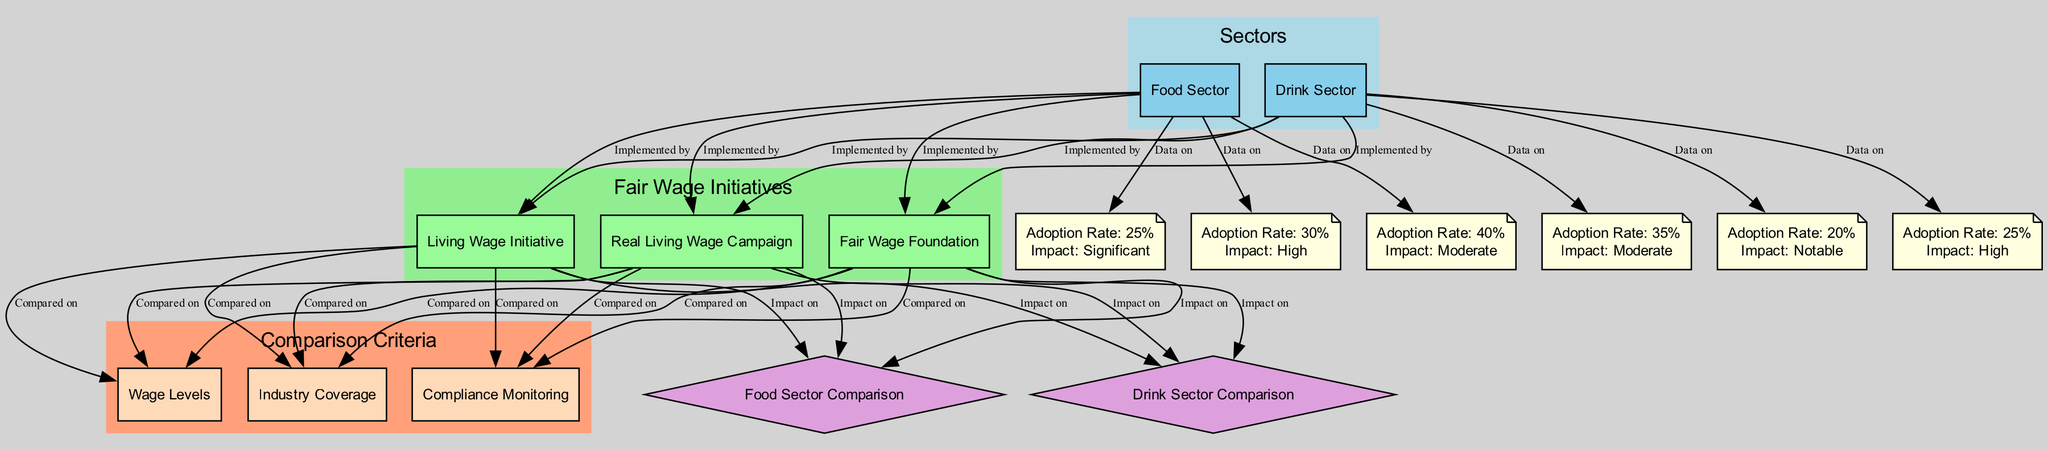What initiatives are implemented in the food sector? The food sector has three initiatives listed: the Living Wage Initiative, the Fair Wage Foundation, and the Real Living Wage Campaign, all connected with "Implemented by" edges.
Answer: Living Wage Initiative, Fair Wage Foundation, Real Living Wage Campaign What is the adoption rate of the Real Living Wage Campaign in the drink sector? The drink sector shows an adoption rate of 25% for the Real Living Wage Campaign, which is indicated in the data provided for that initiative specifically tied to the drink sector.
Answer: 25% Which initiative has the highest impact in the food sector according to the diagram? Examining the impact ratings for the initiatives in the food sector, the Real Living Wage Campaign has the highest impact, noted as "High" in the data associations.
Answer: High How many comparison criteria are there for fair wage initiatives? There are three comparison criteria listed: Wage Levels, Industry Coverage, and Compliance Monitoring, each represented as nodes in the diagram.
Answer: 3 What is the difference in adoption rates between the Fair Wage Foundation in the food sector and the drink sector? In the food sector, the adoption rate of the Fair Wage Foundation is 25%, whereas in the drink sector it is 20%. Subtracting these figures shows a difference of 5%.
Answer: 5% Which sector has a higher adoption rate for the Living Wage Initiative? The adoption rates for the Living Wage Initiative are 40% in the food sector and 35% in the drink sector, therefore the food sector has a higher adoption rate.
Answer: Food Sector What is the significance of compliance monitoring in the comparison of fair wage initiatives? Compliance Monitoring is a shared comparison criterion for all three initiatives, indicating the importance of ensuring adherence to the wage standards set by the initiatives and their effectiveness.
Answer: Important Which initiative is associated with the highest adoption rate in the food sector? The highest adoption rate in the food sector is associated with the Living Wage Initiative at 40%, as indicated in the data connection.
Answer: 40% Which initiative has the lowest adoption rate in the drink sector? The Fair Wage Foundation has the lowest adoption rate in the drink sector, recorded at 20%, which is reflected in the data associations for that sector.
Answer: 20 